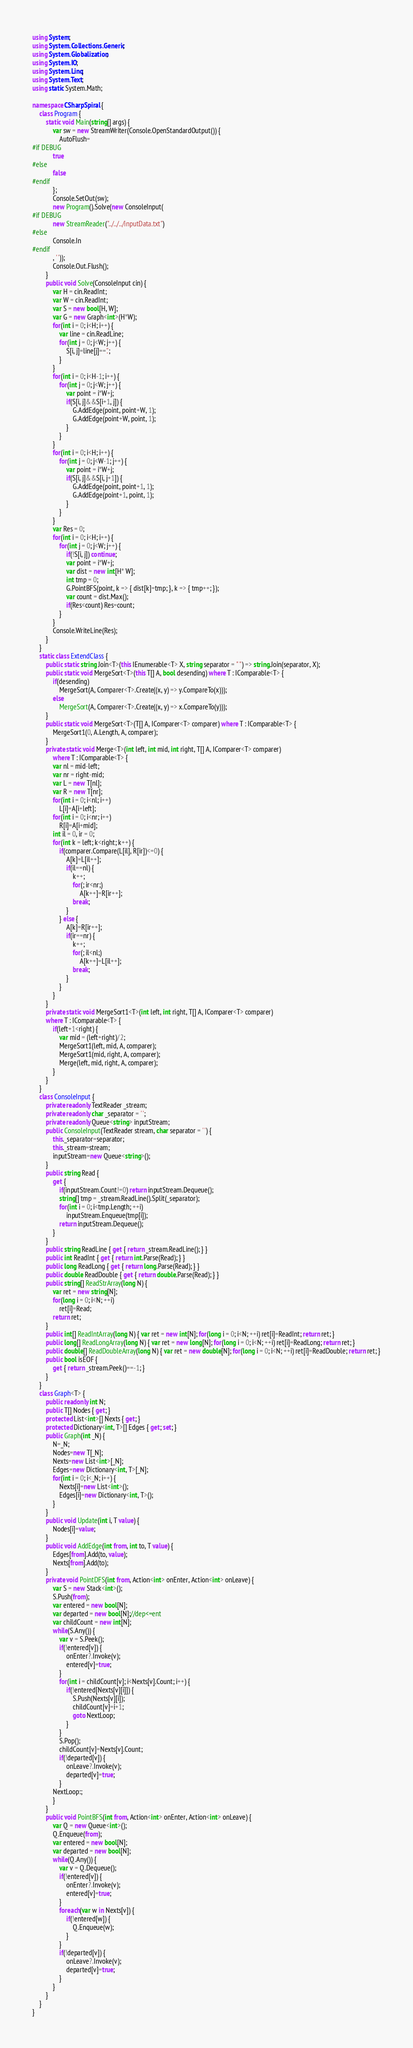<code> <loc_0><loc_0><loc_500><loc_500><_C#_>using System;
using System.Collections.Generic;
using System.Globalization;
using System.IO;
using System.Linq;
using System.Text;
using static System.Math;

namespace CSharpSpiral {
	class Program {
		static void Main(string[] args) {
			var sw = new StreamWriter(Console.OpenStandardOutput()) {
				AutoFlush=
#if DEBUG
			true
#else
			false
#endif
			};
			Console.SetOut(sw);
			new Program().Solve(new ConsoleInput(
#if DEBUG
			new StreamReader("../../../inputData.txt")
#else
			Console.In
#endif
			, ' '));
			Console.Out.Flush();
		}
		public void Solve(ConsoleInput cin) {
			var H = cin.ReadInt;
			var W = cin.ReadInt;
			var S = new bool[H, W];
			var G = new Graph<int>(H*W);
			for(int i = 0; i<H; i++) {
				var line = cin.ReadLine;
				for(int j = 0; j<W; j++) {
					S[i, j]=line[j]=='.'; 
				}
			}
			for(int i = 0; i<H-1; i++) {
				for(int j = 0; j<W; j++) {
					var point = i*W+j;
					if(S[i, j]&&S[i+1, j]) {
						G.AddEdge(point, point+W, 1);
						G.AddEdge(point+W, point, 1);
					}
				}
			}
			for(int i = 0; i<H; i++) {
				for(int j = 0; j<W-1; j++) {
					var point = i*W+j;
					if(S[i, j]&&S[i, j+1]) {
						G.AddEdge(point, point+1, 1);
						G.AddEdge(point+1, point, 1);
					}
				}
			}
			var Res = 0;
			for(int i = 0; i<H; i++) {
				for(int j = 0; j<W; j++) {
					if(!S[i, j]) continue;
					var point = i*W+j;
					var dist = new int[H* W];
					int tmp = 0;
					G.PointBFS(point, k => { dist[k]=tmp; }, k => { tmp++; });
					var count = dist.Max();
					if(Res<count) Res=count;
				}
			}
			Console.WriteLine(Res);
		}
	}
	static class ExtendClass {
		public static string Join<T>(this IEnumerable<T> X, string separator = " ") => string.Join(separator, X);
		public static void MergeSort<T>(this T[] A, bool desending) where T : IComparable<T> {
			if(desending)
				MergeSort(A, Comparer<T>.Create((x, y) => y.CompareTo(x)));
			else
				MergeSort(A, Comparer<T>.Create((x, y) => x.CompareTo(y)));
		}
		public static void MergeSort<T>(T[] A, IComparer<T> comparer) where T : IComparable<T> {
			MergeSort1(0, A.Length, A, comparer);
		}
		private static void Merge<T>(int left, int mid, int right, T[] A, IComparer<T> comparer)
			where T : IComparable<T> {
			var nl = mid-left;
			var nr = right-mid;
			var L = new T[nl];
			var R = new T[nr];
			for(int i = 0; i<nl; i++)
				L[i]=A[i+left];
			for(int i = 0; i<nr; i++)
				R[i]=A[i+mid];
			int il = 0, ir = 0;
			for(int k = left; k<right; k++) {
				if(comparer.Compare(L[il], R[ir])<=0) {
					A[k]=L[il++];
					if(il==nl) {
						k++;
						for(; ir<nr;)
							A[k++]=R[ir++];
						break;
					}
				} else {
					A[k]=R[ir++];
					if(ir==nr) {
						k++;
						for(; il<nl;)
							A[k++]=L[il++];
						break;
					}
				}
			}
		}
		private static void MergeSort1<T>(int left, int right, T[] A, IComparer<T> comparer)
		where T : IComparable<T> {
			if(left+1<right) {
				var mid = (left+right)/2;
				MergeSort1(left, mid, A, comparer);
				MergeSort1(mid, right, A, comparer);
				Merge(left, mid, right, A, comparer);
			}
		}
	}
	class ConsoleInput {
		private readonly TextReader _stream;
		private readonly char _separator = ' ';
		private readonly Queue<string> inputStream;
		public ConsoleInput(TextReader stream, char separator = ' ') {
			this._separator=separator;
			this._stream=stream;
			inputStream=new Queue<string>();
		}
		public string Read {
			get {
				if(inputStream.Count!=0) return inputStream.Dequeue();
				string[] tmp = _stream.ReadLine().Split(_separator);
				for(int i = 0; i<tmp.Length; ++i)
					inputStream.Enqueue(tmp[i]);
				return inputStream.Dequeue();
			}
		}
		public string ReadLine { get { return _stream.ReadLine(); } }
		public int ReadInt { get { return int.Parse(Read); } }
		public long ReadLong { get { return long.Parse(Read); } }
		public double ReadDouble { get { return double.Parse(Read); } }
		public string[] ReadStrArray(long N) {
			var ret = new string[N];
			for(long i = 0; i<N; ++i)
				ret[i]=Read;
			return ret;
		}
		public int[] ReadIntArray(long N) { var ret = new int[N]; for(long i = 0; i<N; ++i) ret[i]=ReadInt; return ret; }
		public long[] ReadLongArray(long N) { var ret = new long[N]; for(long i = 0; i<N; ++i) ret[i]=ReadLong; return ret; }
		public double[] ReadDoubleArray(long N) { var ret = new double[N]; for(long i = 0; i<N; ++i) ret[i]=ReadDouble; return ret; }
		public bool isEOF {
			get { return _stream.Peek()==-1; }
		}
	}
	class Graph<T> {
		public readonly int N;
		public T[] Nodes { get; }
		protected List<int>[] Nexts { get; }
		protected Dictionary<int, T>[] Edges { get; set; }
		public Graph(int _N) {
			N=_N;
			Nodes=new T[_N];
			Nexts=new List<int>[_N];
			Edges=new Dictionary<int, T>[_N];
			for(int i = 0; i<_N; i++) {
				Nexts[i]=new List<int>();
				Edges[i]=new Dictionary<int, T>();
			}
		}
		public void Update(int i, T value) {
			Nodes[i]=value;
		}
		public void AddEdge(int from, int to, T value) {
			Edges[from].Add(to, value);
			Nexts[from].Add(to);
		}
		private void PointDFS(int from, Action<int> onEnter, Action<int> onLeave) {
			var S = new Stack<int>();
			S.Push(from);
			var entered = new bool[N];
			var departed = new bool[N];//dep<=ent
			var childCount = new int[N];
			while(S.Any()) {
				var v = S.Peek();
				if(!entered[v]) {
					onEnter?.Invoke(v);
					entered[v]=true;
				}
				for(int i = childCount[v]; i<Nexts[v].Count; i++) {
					if(!entered[Nexts[v][i]]) {
						S.Push(Nexts[v][i]);
						childCount[v]=i+1;
						goto NextLoop;
					}
				}
				S.Pop();
				childCount[v]=Nexts[v].Count;
				if(!departed[v]) {
					onLeave?.Invoke(v);
					departed[v]=true;
				}
			NextLoop:;
			}
		}
		public void PointBFS(int from, Action<int> onEnter, Action<int> onLeave) {
			var Q = new Queue<int>();
			Q.Enqueue(from);
			var entered = new bool[N];
			var departed = new bool[N];
			while(Q.Any()) {
				var v = Q.Dequeue();
				if(!entered[v]) {
					onEnter?.Invoke(v);
					entered[v]=true;
				}
				foreach(var w in Nexts[v]) {
					if(!entered[w]) {
						Q.Enqueue(w);
					}
				}
				if(!departed[v]) {
					onLeave?.Invoke(v);
					departed[v]=true;
				}
			}
		}
	}
}</code> 